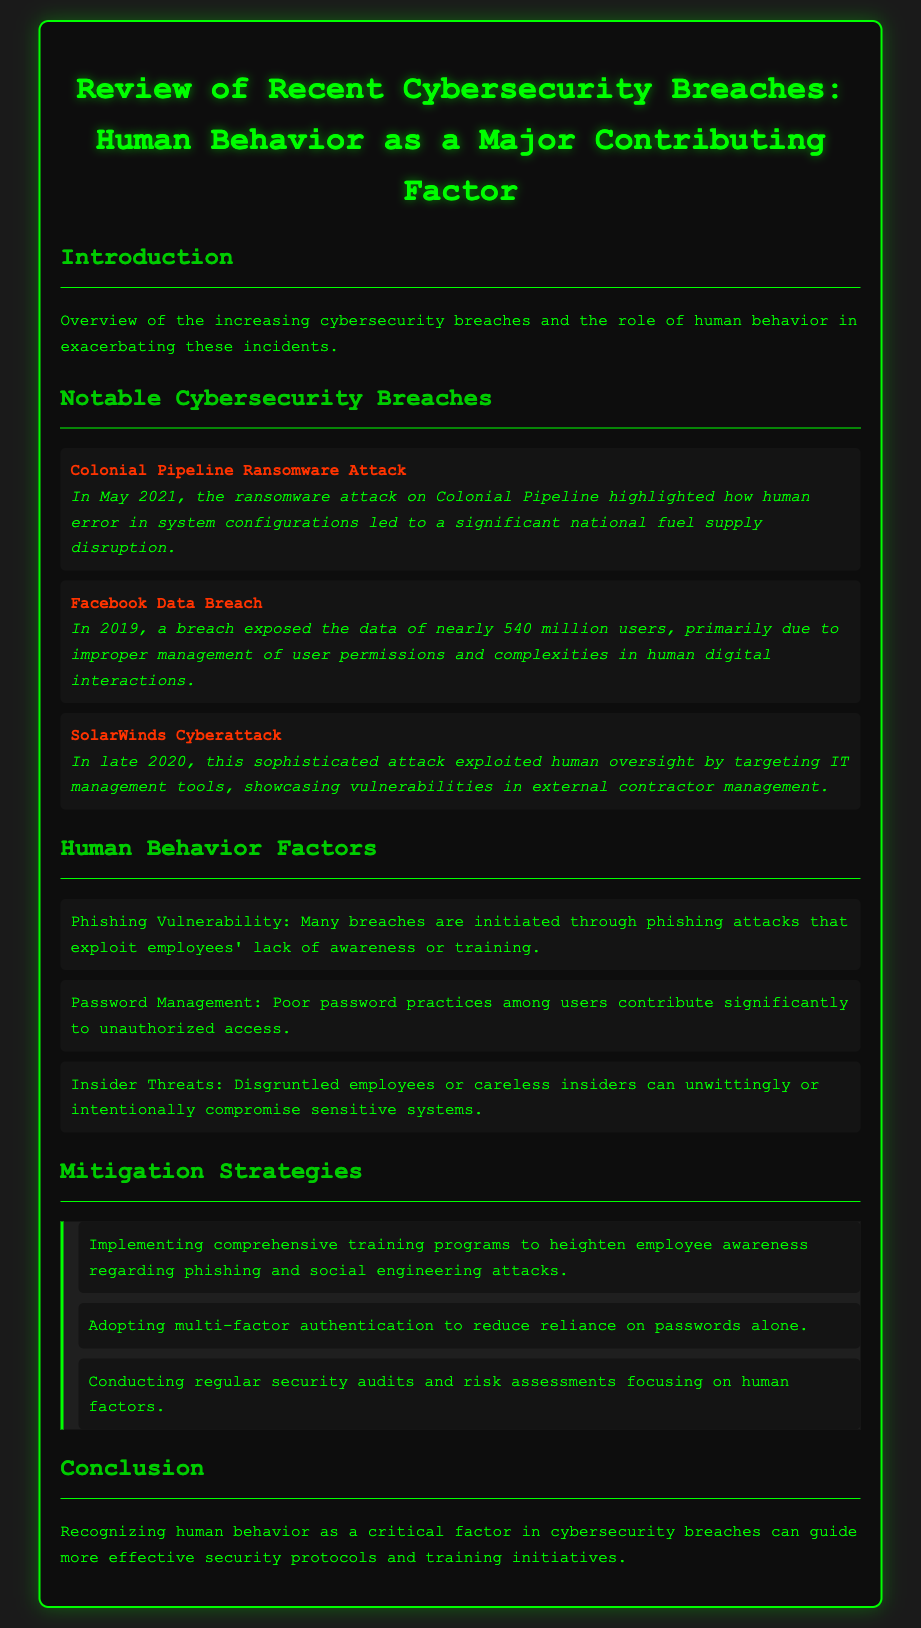what was the date of the Colonial Pipeline ransomware attack? The date of the Colonial Pipeline ransomware attack is specified as May 2021 in the document.
Answer: May 2021 how many users' data was exposed in the Facebook Data Breach? The document states that nearly 540 million users' data was exposed in the Facebook Data Breach.
Answer: nearly 540 million what is one factor that contributes to insider threats? The document mentions that disgruntled employees or careless insiders can compromise sensitive systems.
Answer: disgruntled employees which attack highlighted human error in system configurations? The document specifies the Colonial Pipeline ransomware attack as the incident that highlighted human error in system configurations.
Answer: Colonial Pipeline ransomware attack what does the document recommend to mitigate phishing vulnerabilities? The document recommends implementing comprehensive training programs to heighten employee awareness regarding phishing attacks.
Answer: comprehensive training programs what type of authentication does the document suggest adopting? The document suggests adopting multi-factor authentication to enhance security measures.
Answer: multi-factor authentication in which year did the SolarWinds Cyberattack occur? The document indicates that the SolarWinds Cyberattack occurred in late 2020.
Answer: late 2020 what overarching theme does the conclusion emphasize? The conclusion emphasizes recognizing human behavior as a critical factor in cybersecurity breaches.
Answer: recognizing human behavior as a critical factor 